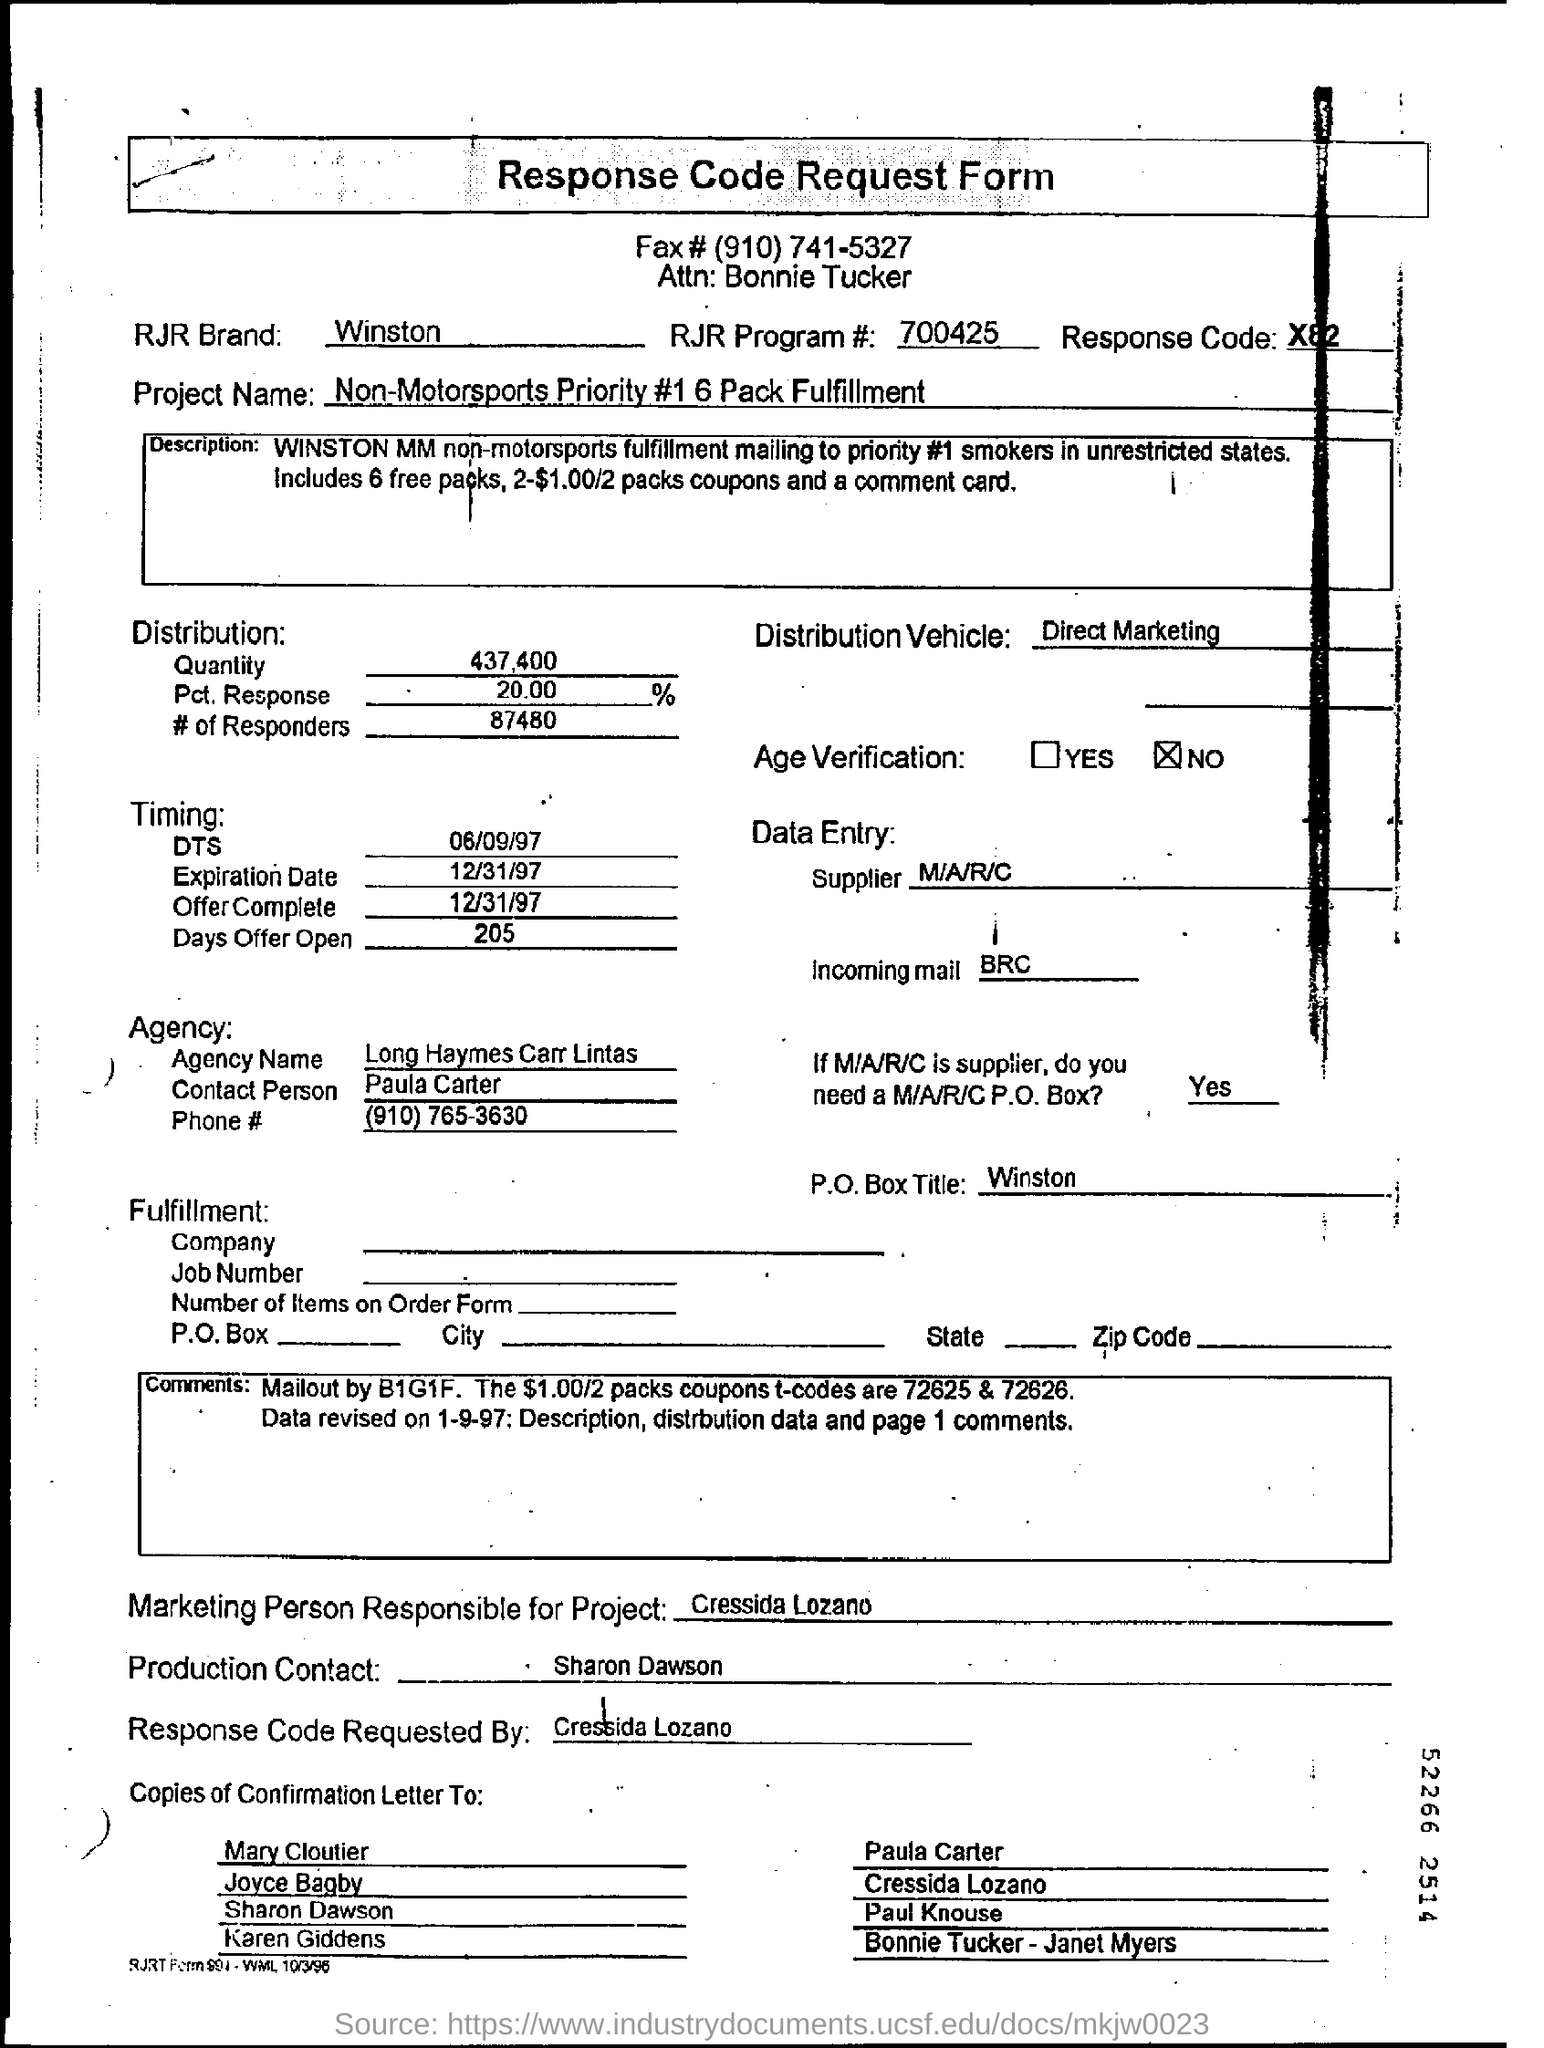Point out several critical features in this image. The project name is Non-Motorsports Priority #1 6 Pack Fulfillment. The brand mentioned is RJR and it is WINSTON. The response code mentioned is X82. The RJR Program # is 700425. 